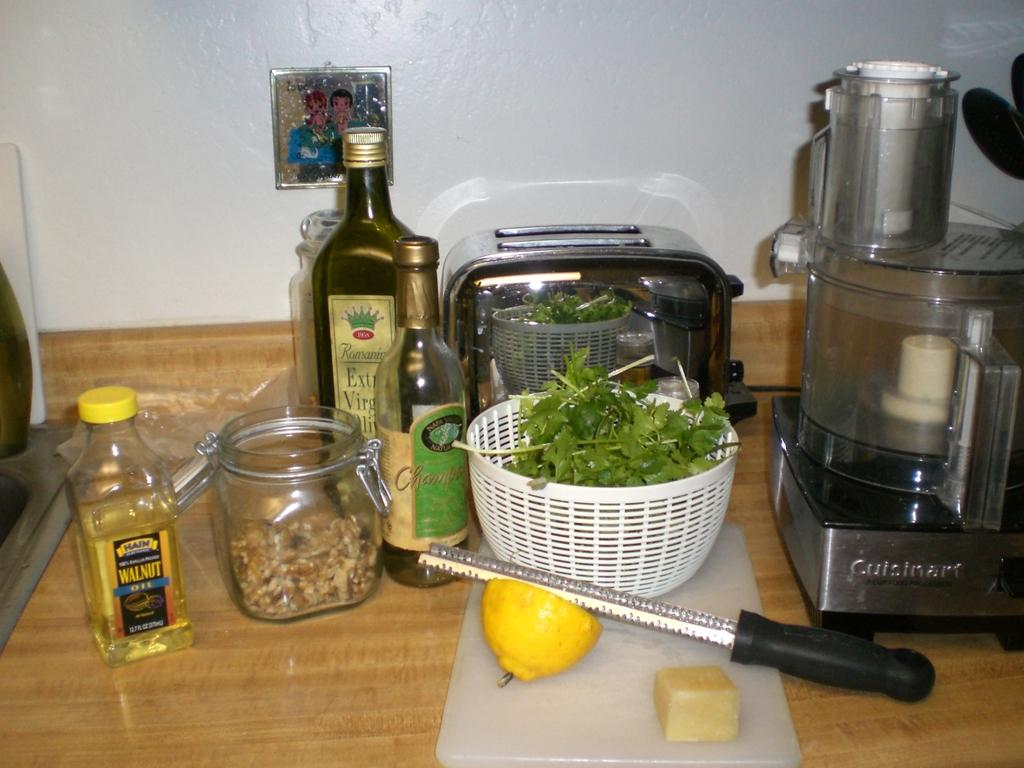Provide a one-sentence caption for the provided image. Hain Walnut oil and Romaine Extra Virgin oil can be seen on this table. 